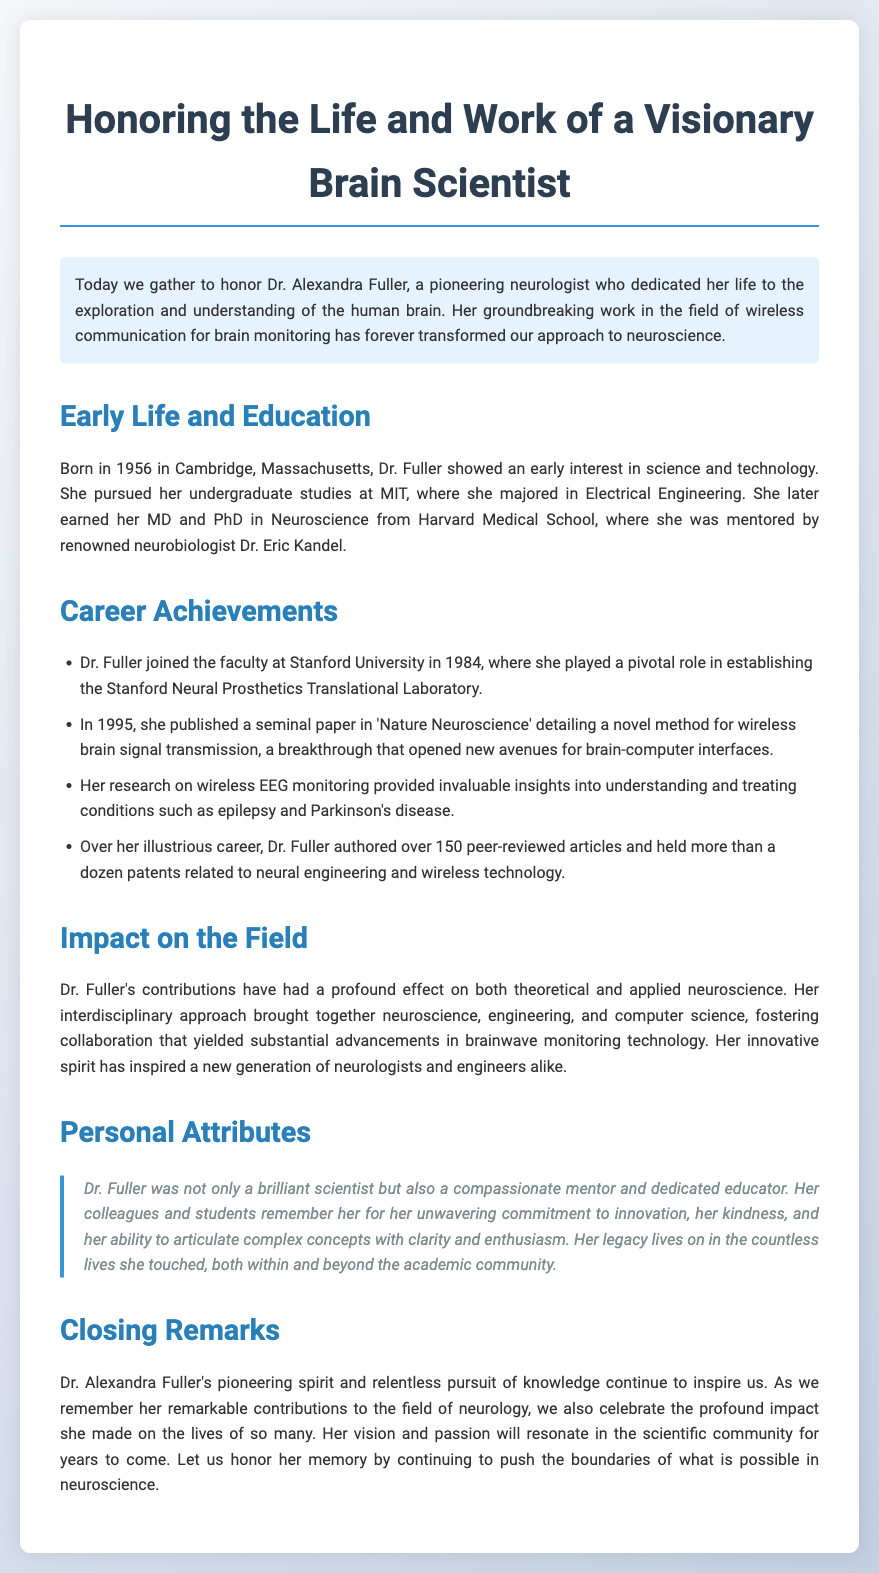What year was Dr. Fuller born? The document states that Dr. Fuller was born in 1956.
Answer: 1956 Where did Dr. Fuller earn her undergraduate degree? The document mentions that she pursued her undergraduate studies at MIT.
Answer: MIT What journal published Dr. Fuller's seminal paper in 1995? The document specifies that her paper was published in 'Nature Neuroscience'.
Answer: Nature Neuroscience How many peer-reviewed articles did Dr. Fuller author over her career? The document indicates that she authored over 150 peer-reviewed articles.
Answer: over 150 What was Dr. Fuller's role at Stanford University? The document states that she played a pivotal role in establishing the Stanford Neural Prosthetics Translational Laboratory.
Answer: establishing the Stanford Neural Prosthetics Translational Laboratory What interdisciplinary approach did Dr. Fuller promote? The document highlights her approach combining neuroscience, engineering, and computer science.
Answer: neuroscience, engineering, and computer science What personal attributes of Dr. Fuller are highlighted in the document? The document mentions her as a brilliant scientist, compassionate mentor, and dedicated educator.
Answer: brilliant scientist, compassionate mentor, and dedicated educator What legacy did Dr. Fuller leave behind? The document states her legacy lives on in the countless lives she touched.
Answer: countless lives she touched 